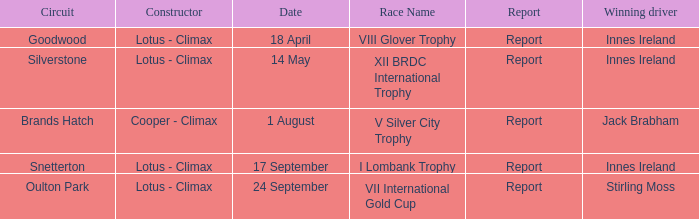What is the name of the race where Stirling Moss was the winning driver? VII International Gold Cup. 